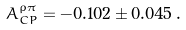<formula> <loc_0><loc_0><loc_500><loc_500>A _ { C P } ^ { \rho \pi } = - 0 . 1 0 2 \pm 0 . 0 4 5 \, .</formula> 